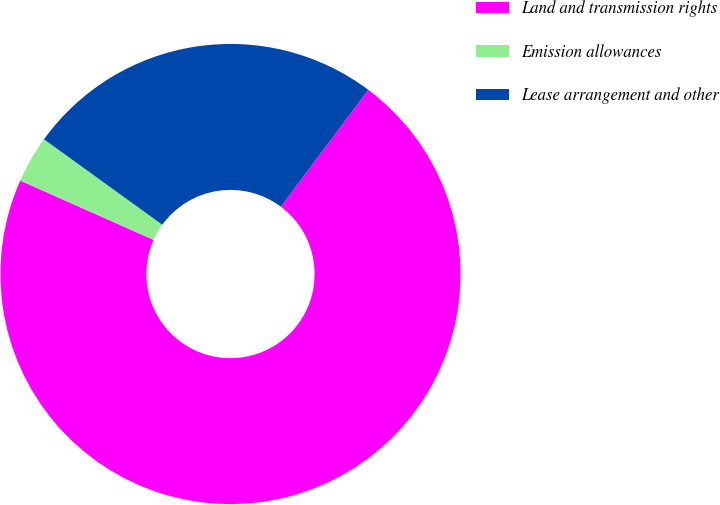<chart> <loc_0><loc_0><loc_500><loc_500><pie_chart><fcel>Land and transmission rights<fcel>Emission allowances<fcel>Lease arrangement and other<nl><fcel>71.43%<fcel>3.3%<fcel>25.27%<nl></chart> 